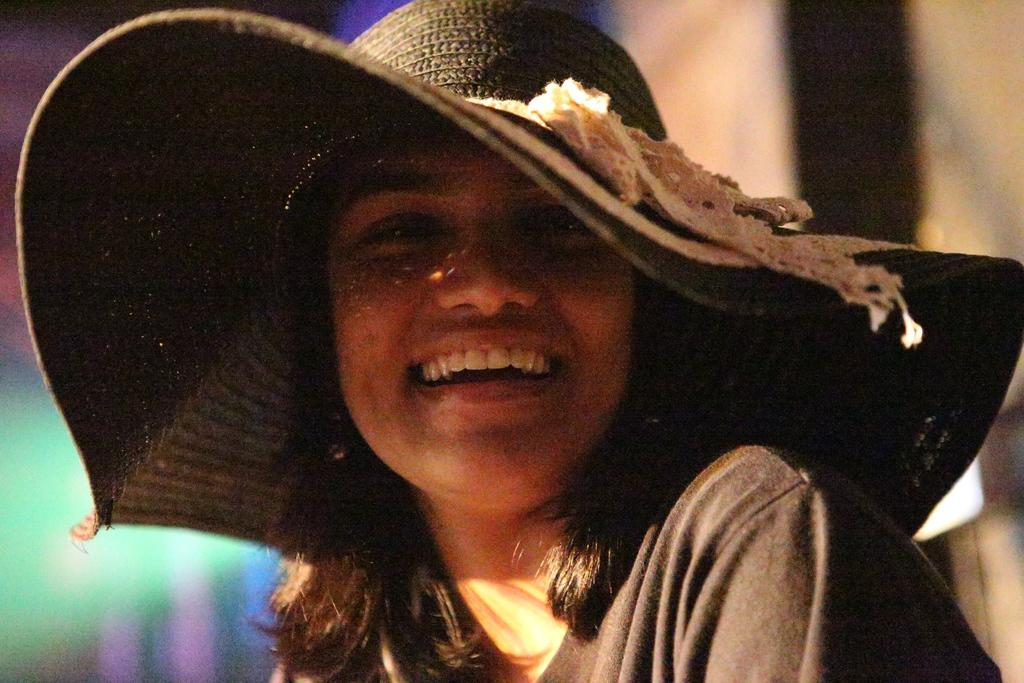Who is the main subject in the image? There is a lady in the center of the image. What is the lady wearing on her head? The lady is wearing a cap. What is the lady's facial expression in the image? The lady is smiling. What type of snail can be seen crawling on the lady's shoulder in the image? There is no snail present on the lady's shoulder in the image. 